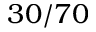Convert formula to latex. <formula><loc_0><loc_0><loc_500><loc_500>3 0 / 7 0</formula> 